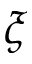<formula> <loc_0><loc_0><loc_500><loc_500>\xi</formula> 